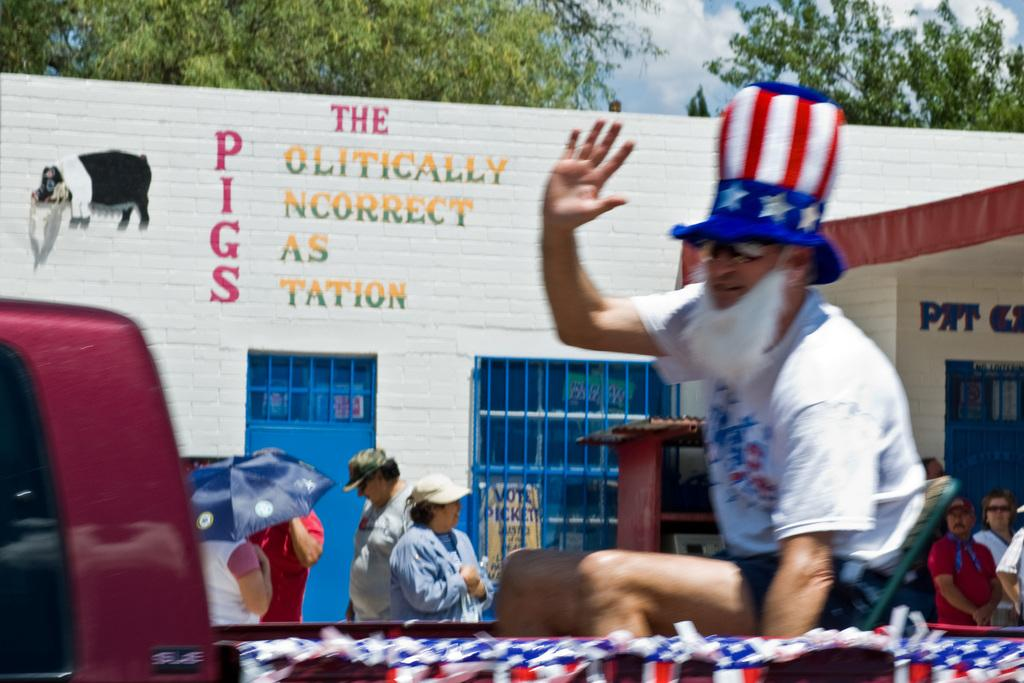<image>
Provide a brief description of the given image. A man wearing a red white and blue hat and a fake beard passes a sign labeled The Politically Incorrect Gas Station. 